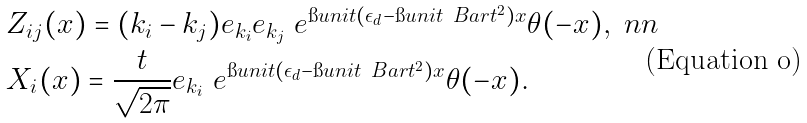<formula> <loc_0><loc_0><loc_500><loc_500>& Z _ { i j } ( x ) = ( k _ { i } - k _ { j } ) e _ { k _ { i } } e _ { k _ { j } } \ e ^ { \i u n i t ( \epsilon _ { d } - \i u n i t \ B a r { t } ^ { 2 } ) x } \theta ( - x ) , \ n n \\ & X _ { i } ( x ) = \frac { t } { \sqrt { 2 \pi } } e _ { k _ { i } } \ e ^ { \i u n i t ( \epsilon _ { d } - \i u n i t \ B a r { t } ^ { 2 } ) x } \theta ( - x ) .</formula> 